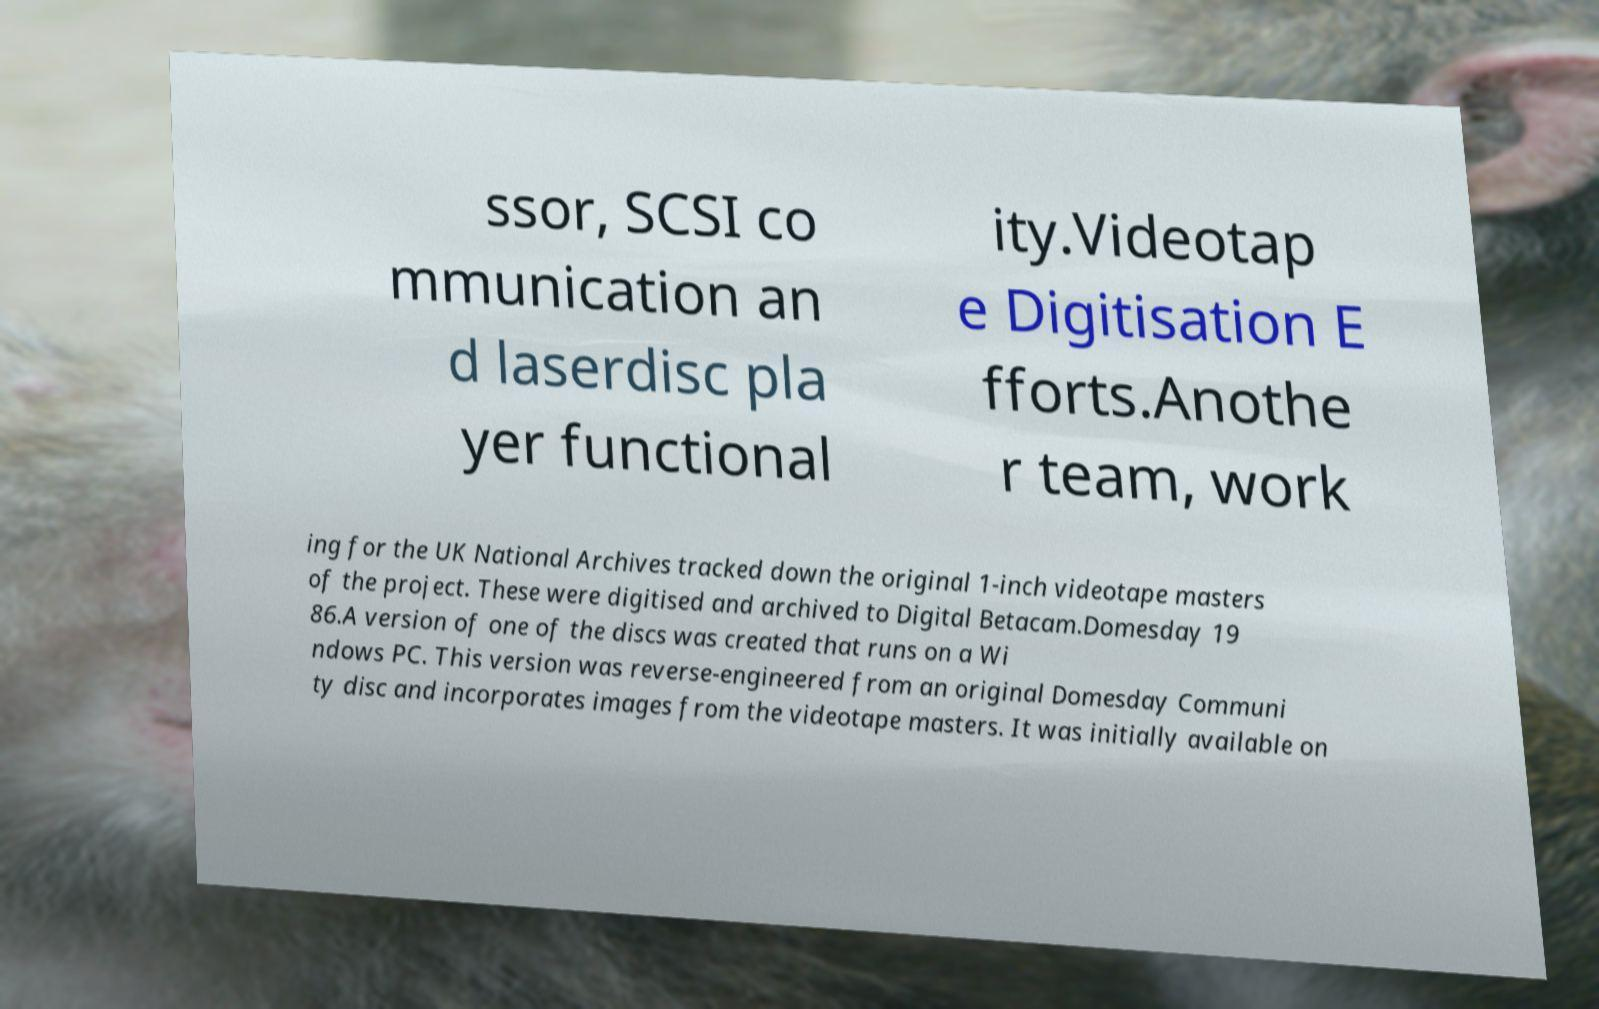There's text embedded in this image that I need extracted. Can you transcribe it verbatim? ssor, SCSI co mmunication an d laserdisc pla yer functional ity.Videotap e Digitisation E fforts.Anothe r team, work ing for the UK National Archives tracked down the original 1-inch videotape masters of the project. These were digitised and archived to Digital Betacam.Domesday 19 86.A version of one of the discs was created that runs on a Wi ndows PC. This version was reverse-engineered from an original Domesday Communi ty disc and incorporates images from the videotape masters. It was initially available on 